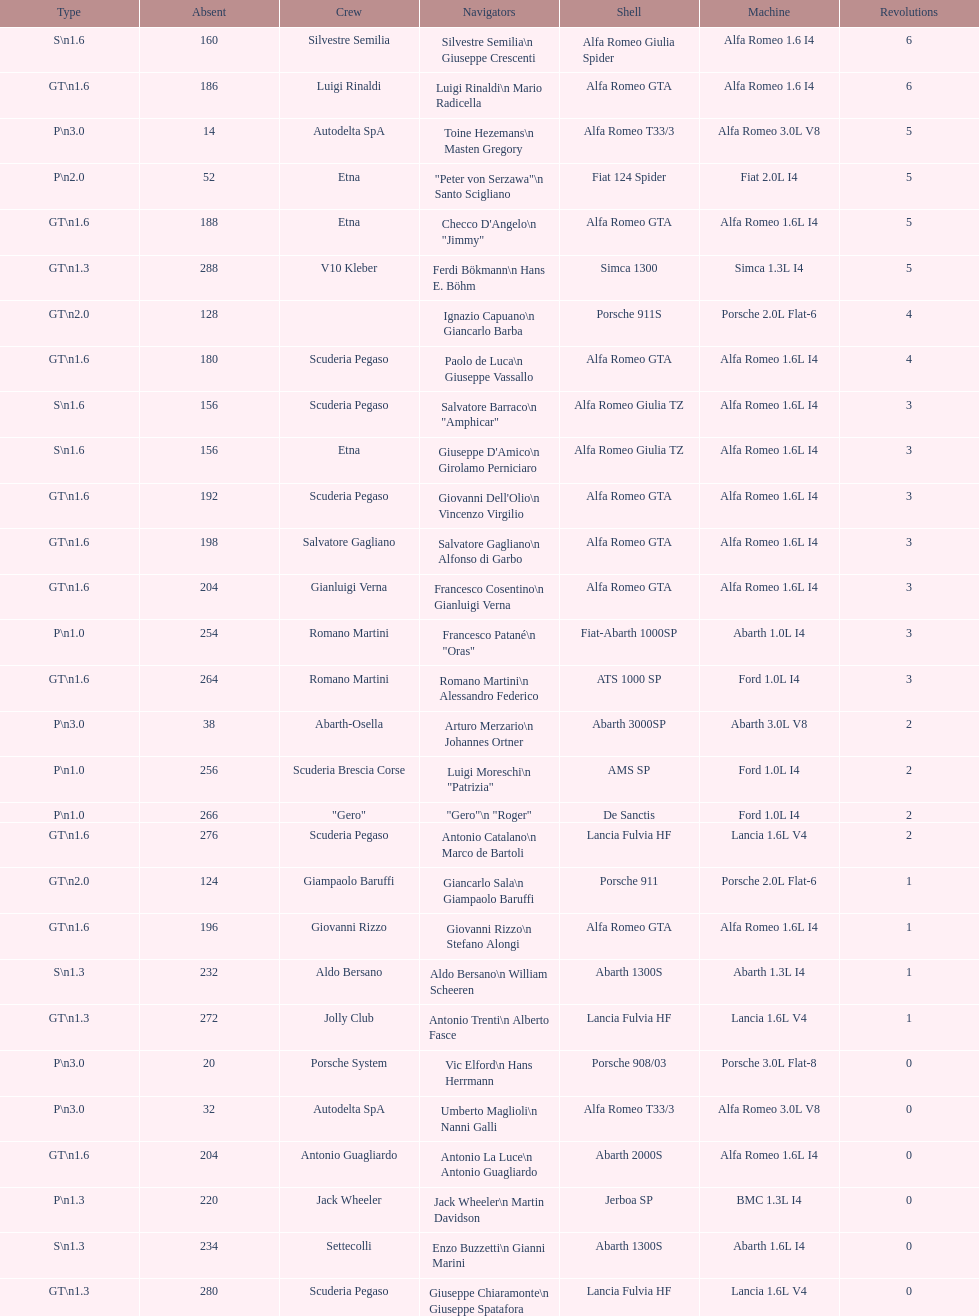His nickname is "jimmy," but what is his full name? Checco D'Angelo. 